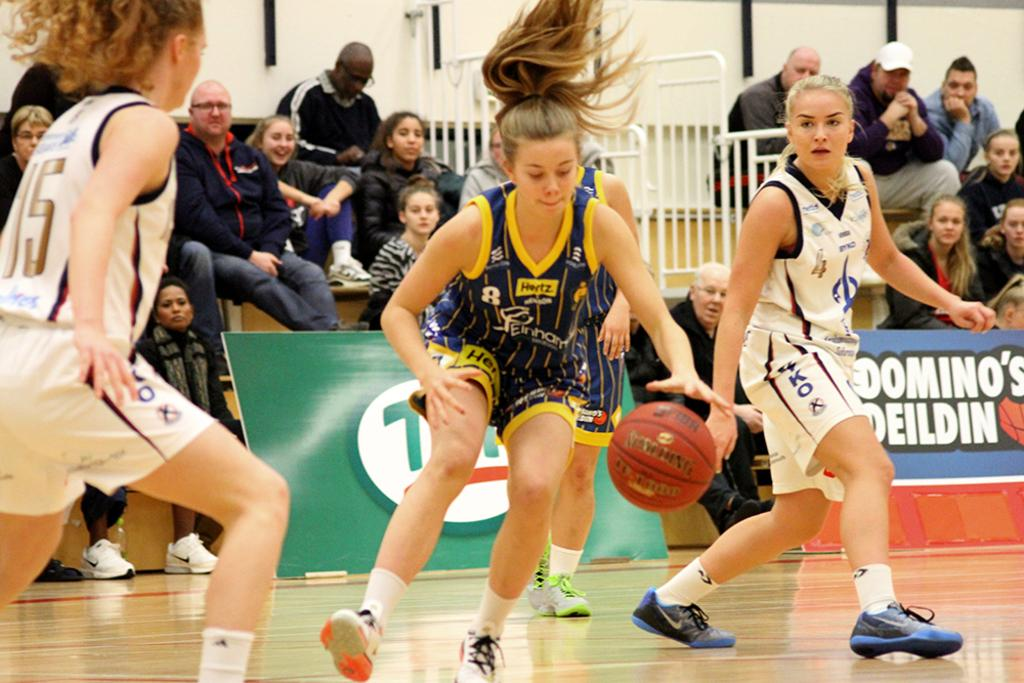<image>
Provide a brief description of the given image. Woman playing basketball with one wearing a jersey number 15. 